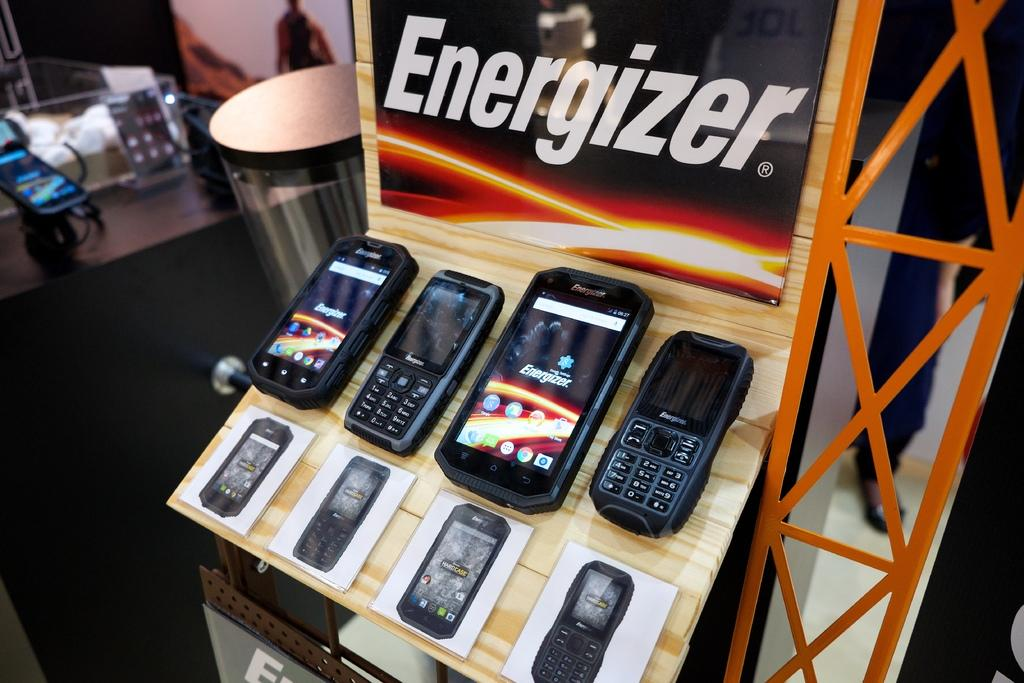<image>
Render a clear and concise summary of the photo. A display with an Energizer banner holds assorted Energizer cellphones. 